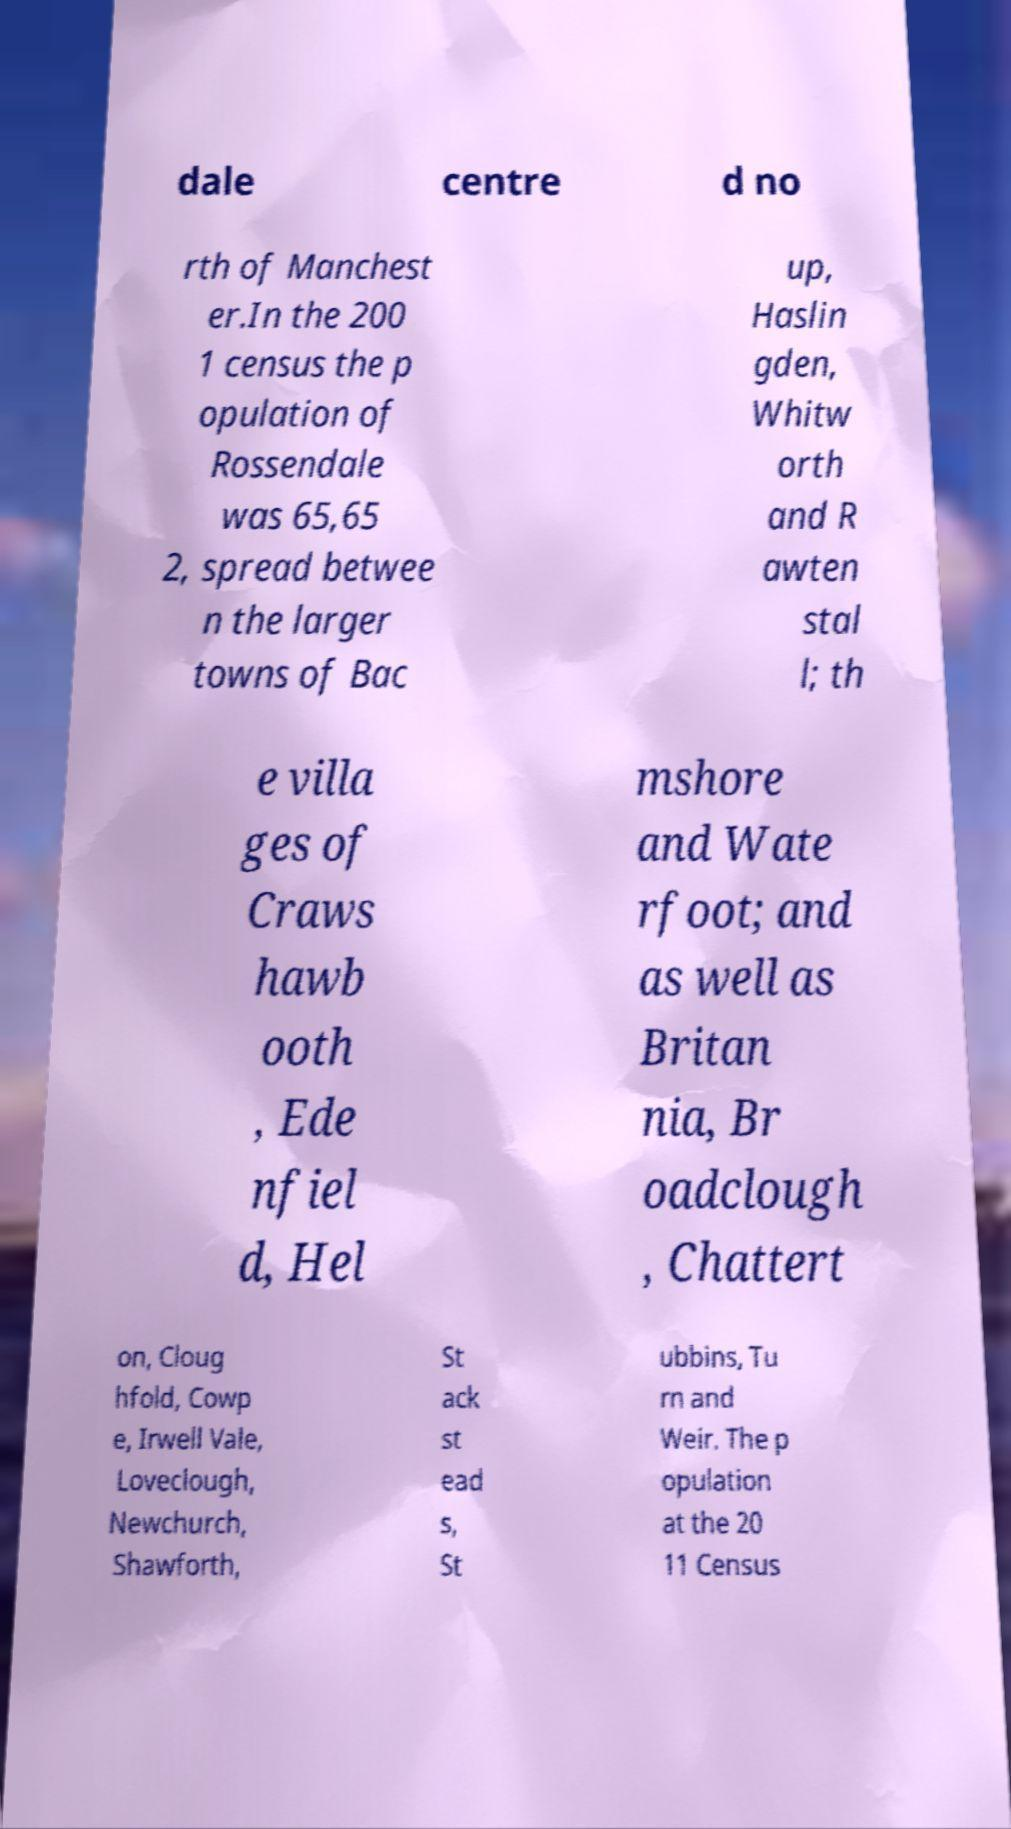Could you extract and type out the text from this image? dale centre d no rth of Manchest er.In the 200 1 census the p opulation of Rossendale was 65,65 2, spread betwee n the larger towns of Bac up, Haslin gden, Whitw orth and R awten stal l; th e villa ges of Craws hawb ooth , Ede nfiel d, Hel mshore and Wate rfoot; and as well as Britan nia, Br oadclough , Chattert on, Cloug hfold, Cowp e, Irwell Vale, Loveclough, Newchurch, Shawforth, St ack st ead s, St ubbins, Tu rn and Weir. The p opulation at the 20 11 Census 